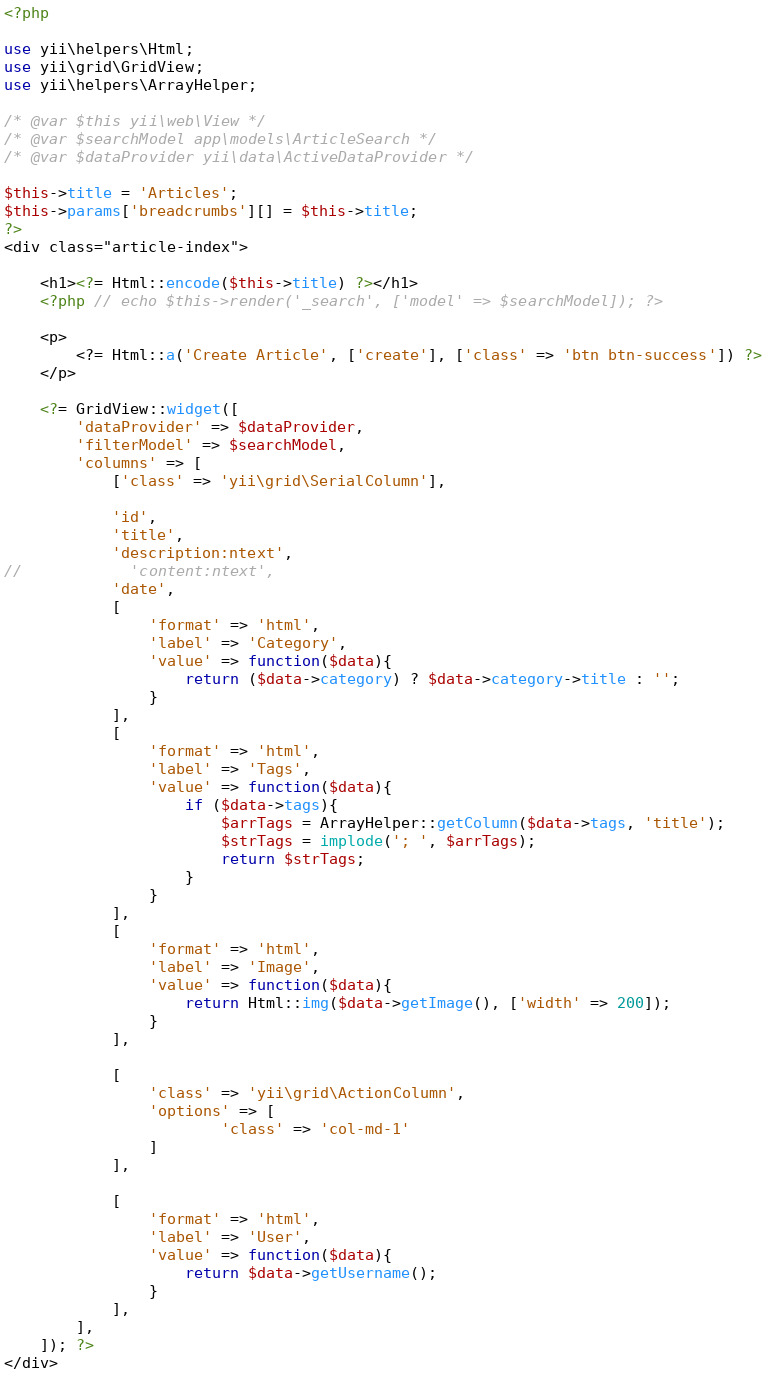<code> <loc_0><loc_0><loc_500><loc_500><_PHP_><?php

use yii\helpers\Html;
use yii\grid\GridView;
use yii\helpers\ArrayHelper;

/* @var $this yii\web\View */
/* @var $searchModel app\models\ArticleSearch */
/* @var $dataProvider yii\data\ActiveDataProvider */

$this->title = 'Articles';
$this->params['breadcrumbs'][] = $this->title;
?>
<div class="article-index">

    <h1><?= Html::encode($this->title) ?></h1>
    <?php // echo $this->render('_search', ['model' => $searchModel]); ?>

    <p>
        <?= Html::a('Create Article', ['create'], ['class' => 'btn btn-success']) ?>
    </p>

    <?= GridView::widget([
        'dataProvider' => $dataProvider,
        'filterModel' => $searchModel,
        'columns' => [
            ['class' => 'yii\grid\SerialColumn'],

            'id',
            'title',
            'description:ntext',
//            'content:ntext',
            'date',
            [
                'format' => 'html',
                'label' => 'Category',
                'value' => function($data){
                    return ($data->category) ? $data->category->title : '';
                }
            ],
            [
                'format' => 'html',
                'label' => 'Tags',
                'value' => function($data){
                    if ($data->tags){
                        $arrTags = ArrayHelper::getColumn($data->tags, 'title');
                        $strTags = implode('; ', $arrTags);
                        return $strTags;
                    }
                }
            ],
            [
                'format' => 'html',
                'label' => 'Image',
                'value' => function($data){
                    return Html::img($data->getImage(), ['width' => 200]);
                }
            ],

            [
                'class' => 'yii\grid\ActionColumn',
                'options' => [
                        'class' => 'col-md-1'
                ]
            ],

            [
                'format' => 'html',
                'label' => 'User',
                'value' => function($data){
                    return $data->getUsername();
                }
            ],
        ],
    ]); ?>
</div>
</code> 